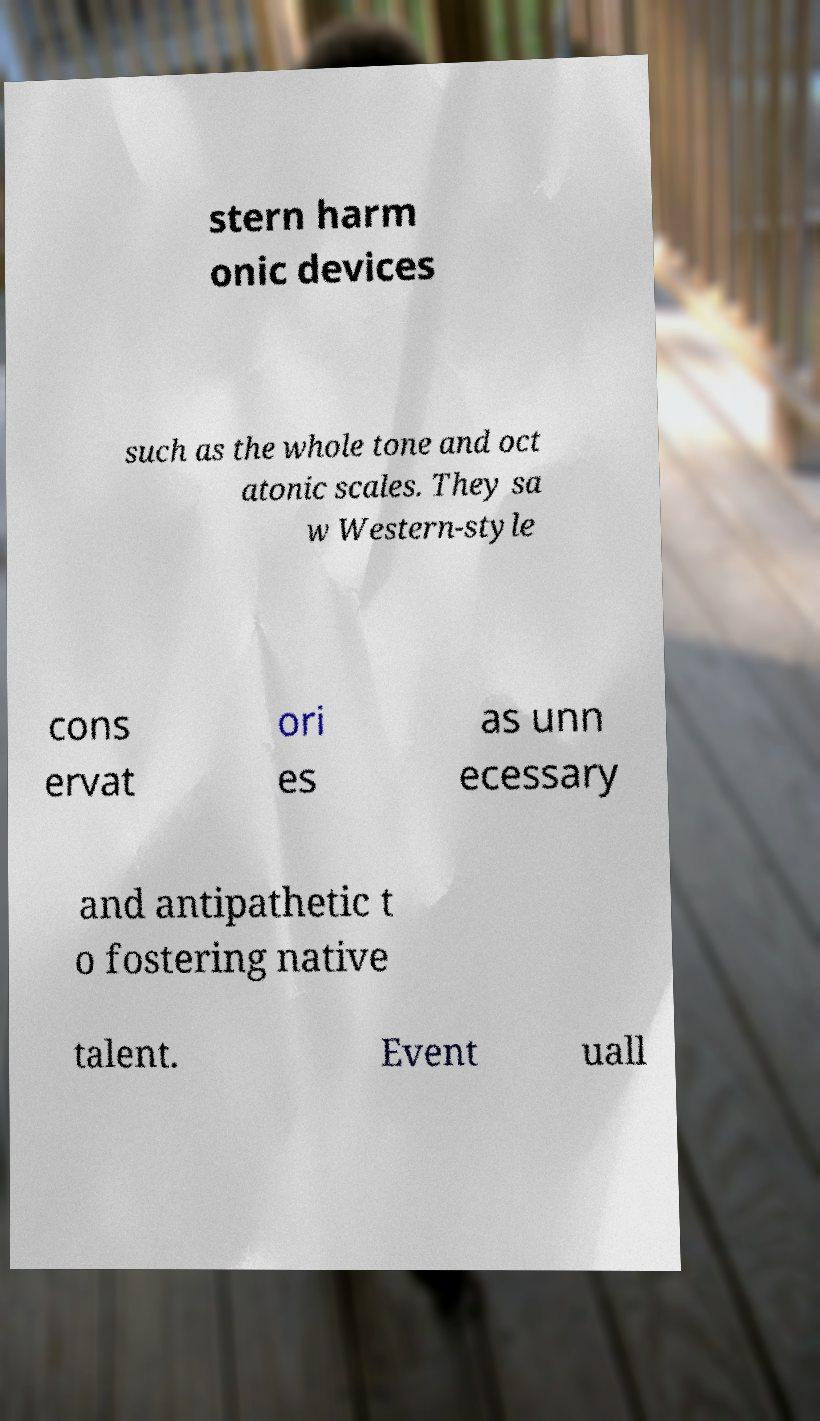For documentation purposes, I need the text within this image transcribed. Could you provide that? stern harm onic devices such as the whole tone and oct atonic scales. They sa w Western-style cons ervat ori es as unn ecessary and antipathetic t o fostering native talent. Event uall 